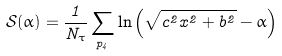<formula> <loc_0><loc_0><loc_500><loc_500>\mathcal { S ( \alpha ) } = \frac { 1 } { N _ { \tau } } \sum _ { p _ { 4 } } \ln \left ( \sqrt { c ^ { 2 } x ^ { 2 } + b ^ { 2 } } - \alpha \right )</formula> 